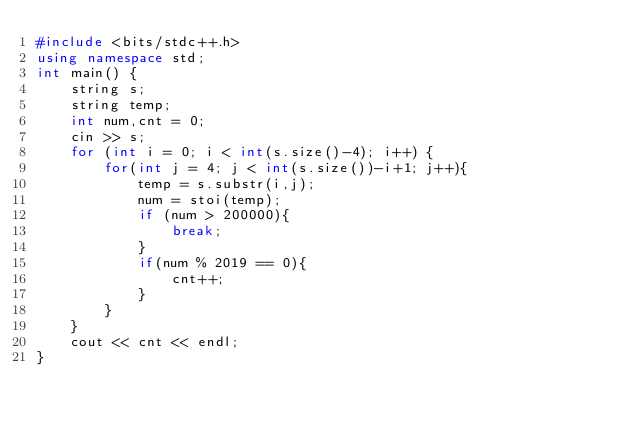Convert code to text. <code><loc_0><loc_0><loc_500><loc_500><_C++_>#include <bits/stdc++.h>
using namespace std;
int main() {
    string s;
    string temp;
    int num,cnt = 0;
    cin >> s;
    for (int i = 0; i < int(s.size()-4); i++) {
        for(int j = 4; j < int(s.size())-i+1; j++){
            temp = s.substr(i,j);
            num = stoi(temp);
            if (num > 200000){
                break;
            }
            if(num % 2019 == 0){
                cnt++;
            }
        }
    }
    cout << cnt << endl;
}</code> 